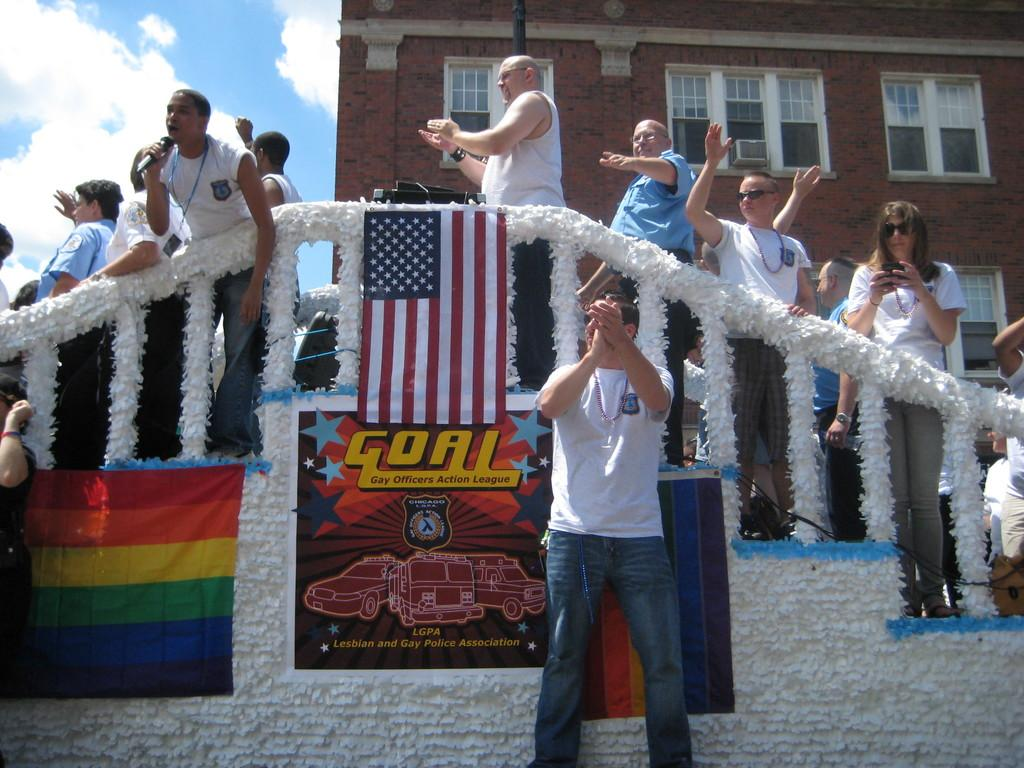How many people are in the image? There are people in the image, but the exact number is not specified. What can be seen near the people in the image? There is railing in the image. What decorative elements are present in the image? There are flags and a poster in the image. What architectural feature is visible in the image? There is a wall in the image. What can be used for ventilation or light in the image? There are windows in the image. What type of structure is present in the image? There is a building in the image. What is visible in the background of the image? The sky is visible in the background of the image, and there are clouds in the sky. What is the tendency of the sand in the image? There is no sand present in the image. How many geese are flying in the image? There are no geese present in the image. 